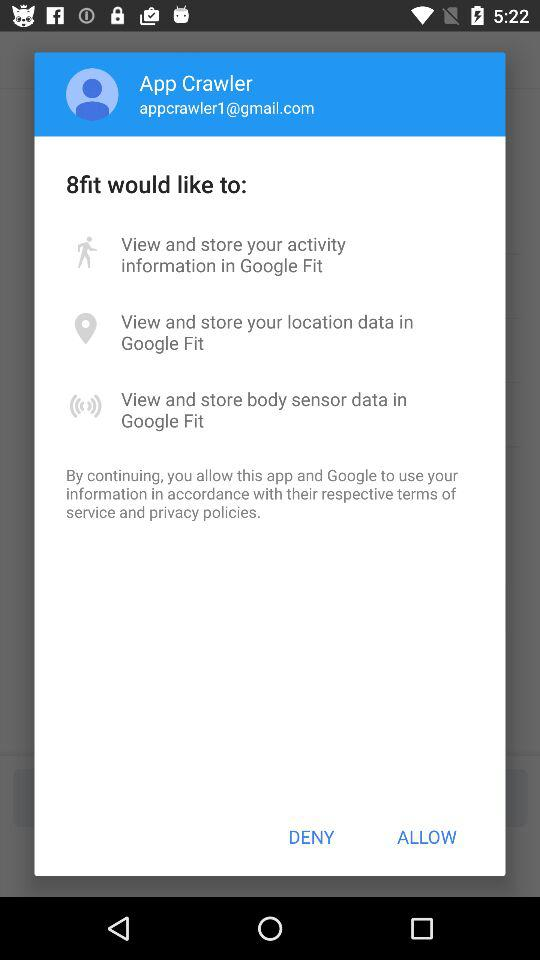What is the name of the user? The name of the user is App Crawler. 